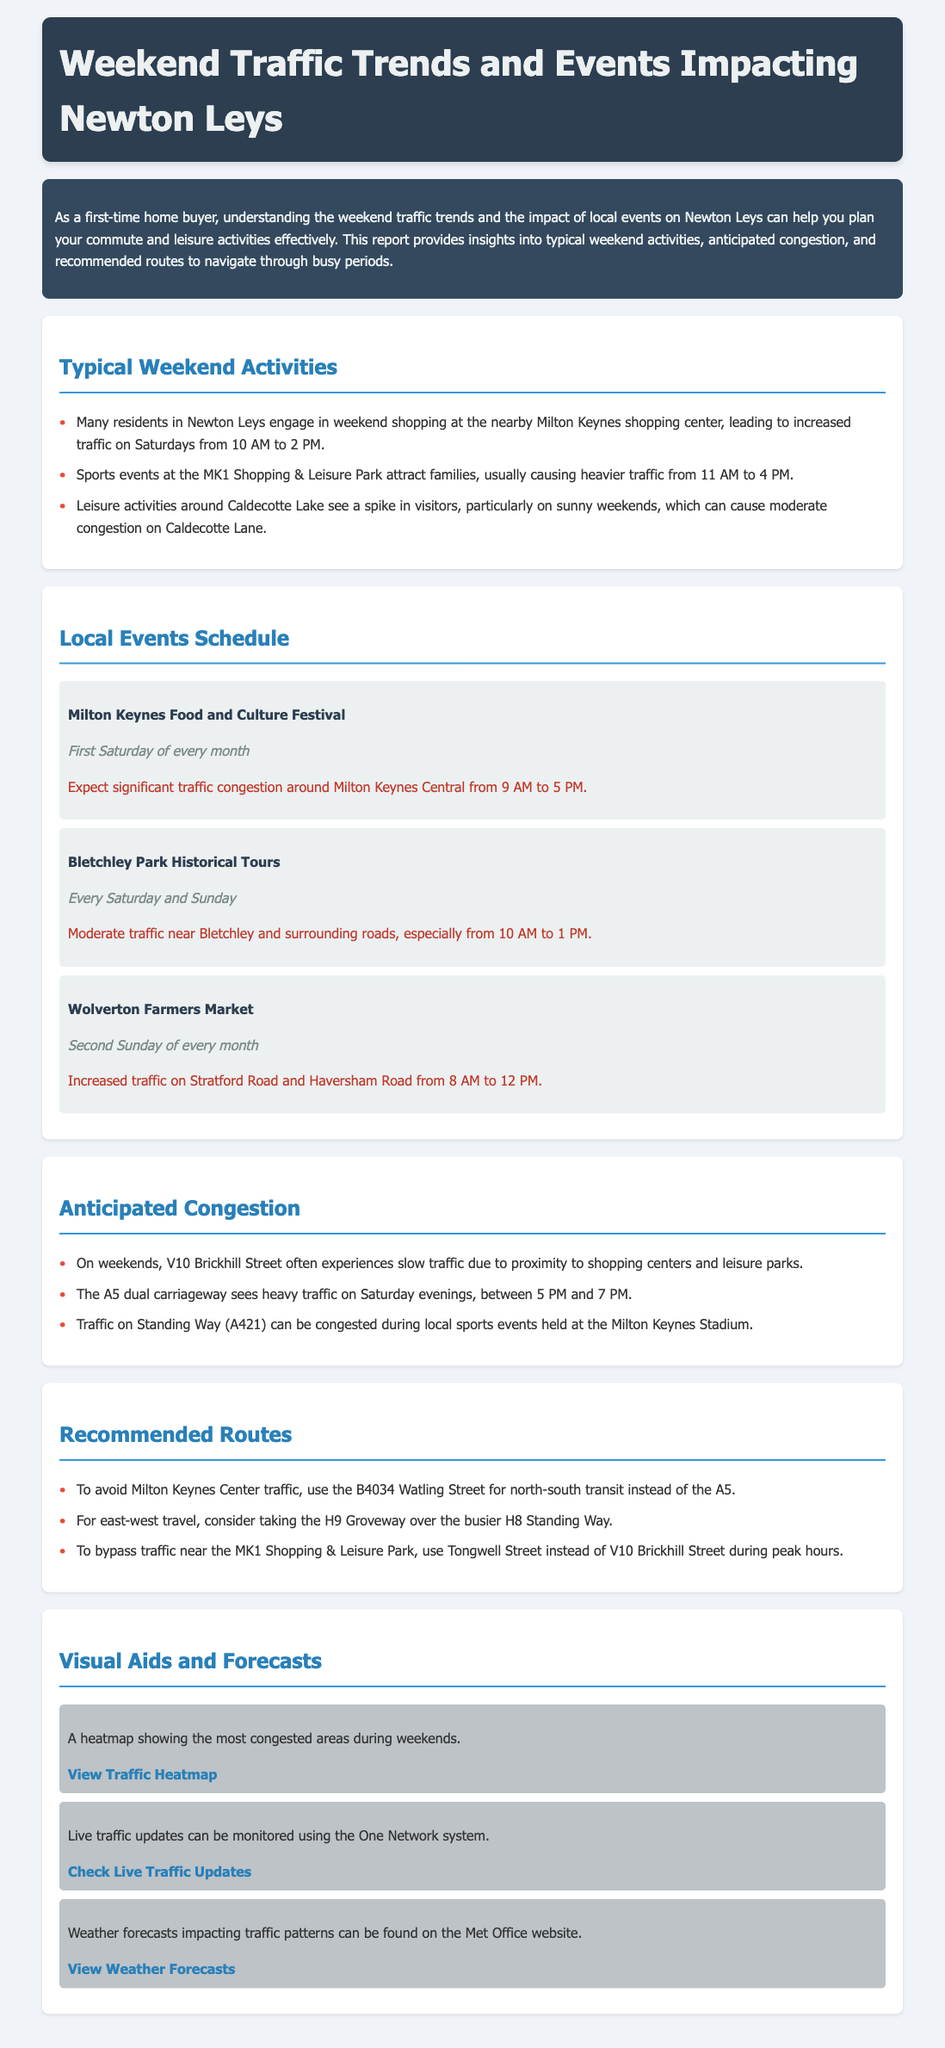What is the peak traffic time on Saturdays for shopping? The document states that many residents engage in weekend shopping at the nearby Milton Keynes shopping center, causing increased traffic on Saturdays from 10 AM to 2 PM.
Answer: 10 AM to 2 PM What event takes place on the first Saturday of every month? The document indicates that the Milton Keynes Food and Culture Festival occurs on the first Saturday of every month.
Answer: Milton Keynes Food and Culture Festival What time does traffic become heavy on Saturday evenings on the A5? The report mentions that the A5 dual carriageway sees heavy traffic on Saturday evenings, particularly between 5 PM and 7 PM.
Answer: 5 PM to 7 PM Which road is recommended to avoid traffic near the MK1 Shopping & Leisure Park? The document advises using Tongwell Street instead of V10 Brickhill Street during peak hours to bypass traffic near the MK1 Shopping & Leisure Park.
Answer: Tongwell Street What is the expected impact of the Bletchley Park Historical Tours? The report notes that there will be moderate traffic near Bletchley and surrounding roads due to the Bletchley Park Historical Tours, especially from 10 AM to 1 PM.
Answer: Moderate traffic What website can be used to view weather forecasts impacting traffic? The document provides the Met Office website to check for weather forecasts that might affect traffic patterns.
Answer: Met Office website 